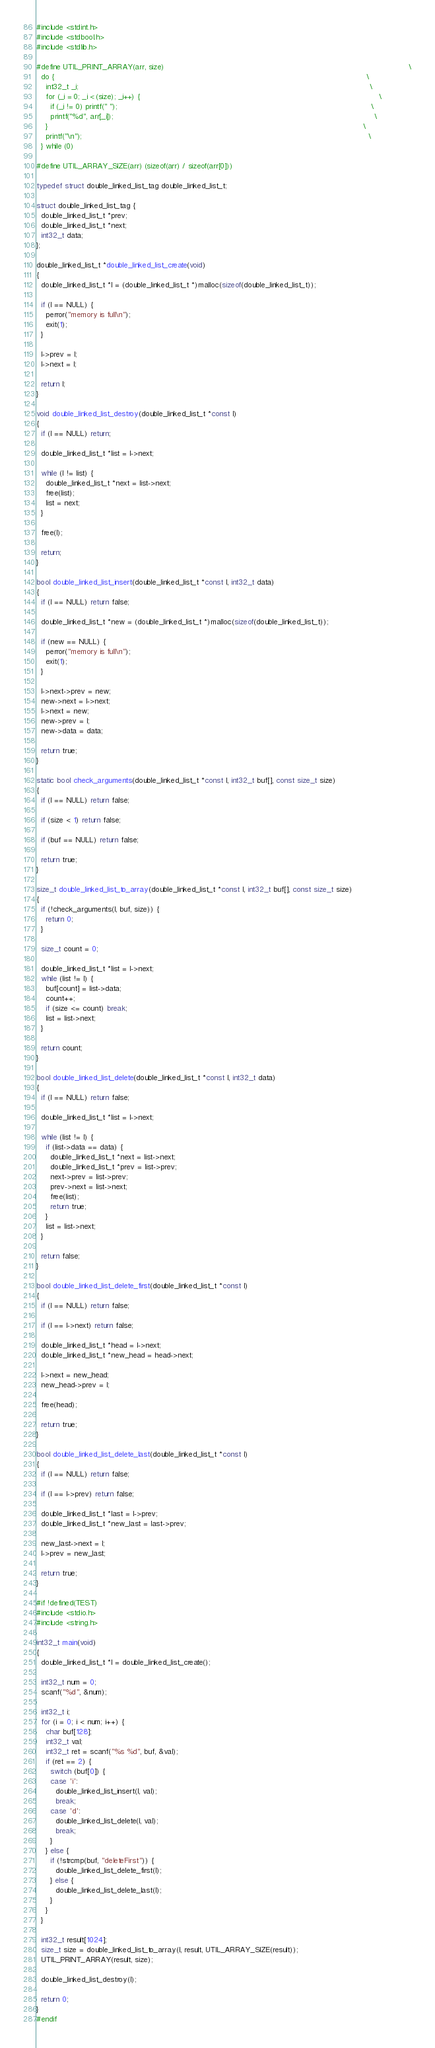Convert code to text. <code><loc_0><loc_0><loc_500><loc_500><_C_>#include <stdint.h>
#include <stdbool.h>
#include <stdlib.h>

#define UTIL_PRINT_ARRAY(arr, size)                                                                                                        \
  do {                                                                                                                                     \
    int32_t _i;                                                                                                                            \
    for (_i = 0; _i < (size); _i++) {                                                                                                      \
      if (_i != 0) printf(" ");                                                                                                            \
      printf("%d", arr[_i]);                                                                                                               \
    }                                                                                                                                      \
    printf("\n");                                                                                                                          \
  } while (0)

#define UTIL_ARRAY_SIZE(arr) (sizeof(arr) / sizeof(arr[0]))

typedef struct double_linked_list_tag double_linked_list_t;

struct double_linked_list_tag {
  double_linked_list_t *prev;
  double_linked_list_t *next;
  int32_t data;
};

double_linked_list_t *double_linked_list_create(void)
{
  double_linked_list_t *l = (double_linked_list_t *)malloc(sizeof(double_linked_list_t));

  if (l == NULL) {
    perror("memory is full\n");
    exit(1);
  }

  l->prev = l;
  l->next = l;

  return l;
}

void double_linked_list_destroy(double_linked_list_t *const l)
{
  if (l == NULL) return;

  double_linked_list_t *list = l->next;

  while (l != list) {
    double_linked_list_t *next = list->next;
    free(list);
    list = next;
  }

  free(l);

  return;
}

bool double_linked_list_insert(double_linked_list_t *const l, int32_t data)
{
  if (l == NULL) return false;

  double_linked_list_t *new = (double_linked_list_t *)malloc(sizeof(double_linked_list_t));

  if (new == NULL) {
    perror("memory is full\n");
    exit(1);
  }

  l->next->prev = new;
  new->next = l->next;
  l->next = new;
  new->prev = l;
  new->data = data;

  return true;
}

static bool check_arguments(double_linked_list_t *const l, int32_t buf[], const size_t size)
{
  if (l == NULL) return false;

  if (size < 1) return false;

  if (buf == NULL) return false;

  return true;
}

size_t double_linked_list_to_array(double_linked_list_t *const l, int32_t buf[], const size_t size)
{
  if (!check_arguments(l, buf, size)) {
    return 0;
  }

  size_t count = 0;

  double_linked_list_t *list = l->next;
  while (list != l) {
    buf[count] = list->data;
    count++;
    if (size <= count) break;
    list = list->next;
  }

  return count;
}

bool double_linked_list_delete(double_linked_list_t *const l, int32_t data)
{
  if (l == NULL) return false;

  double_linked_list_t *list = l->next;

  while (list != l) {
    if (list->data == data) {
      double_linked_list_t *next = list->next;
      double_linked_list_t *prev = list->prev;
      next->prev = list->prev;
      prev->next = list->next;
      free(list);
      return true;
    }
    list = list->next;
  }

  return false;
}

bool double_linked_list_delete_first(double_linked_list_t *const l)
{
  if (l == NULL) return false;

  if (l == l->next) return false;

  double_linked_list_t *head = l->next;
  double_linked_list_t *new_head = head->next;

  l->next = new_head;
  new_head->prev = l;

  free(head);

  return true;
}

bool double_linked_list_delete_last(double_linked_list_t *const l)
{
  if (l == NULL) return false;

  if (l == l->prev) return false;

  double_linked_list_t *last = l->prev;
  double_linked_list_t *new_last = last->prev;

  new_last->next = l;
  l->prev = new_last;

  return true;
}

#if !defined(TEST)
#include <stdio.h>
#include <string.h>

int32_t main(void)
{
  double_linked_list_t *l = double_linked_list_create();

  int32_t num = 0;
  scanf("%d", &num);

  int32_t i;
  for (i = 0; i < num; i++) {
    char buf[128];
    int32_t val;
    int32_t ret = scanf("%s %d", buf, &val);
    if (ret == 2) {
      switch (buf[0]) {
      case 'i':
        double_linked_list_insert(l, val);
        break;
      case 'd':
        double_linked_list_delete(l, val);
        break;
      }
    } else {
      if (!strcmp(buf, "deleteFirst")) {
        double_linked_list_delete_first(l);
      } else {
        double_linked_list_delete_last(l);
      }
    }
  }

  int32_t result[1024];
  size_t size = double_linked_list_to_array(l, result, UTIL_ARRAY_SIZE(result));
  UTIL_PRINT_ARRAY(result, size);

  double_linked_list_destroy(l);

  return 0;
}
#endif</code> 